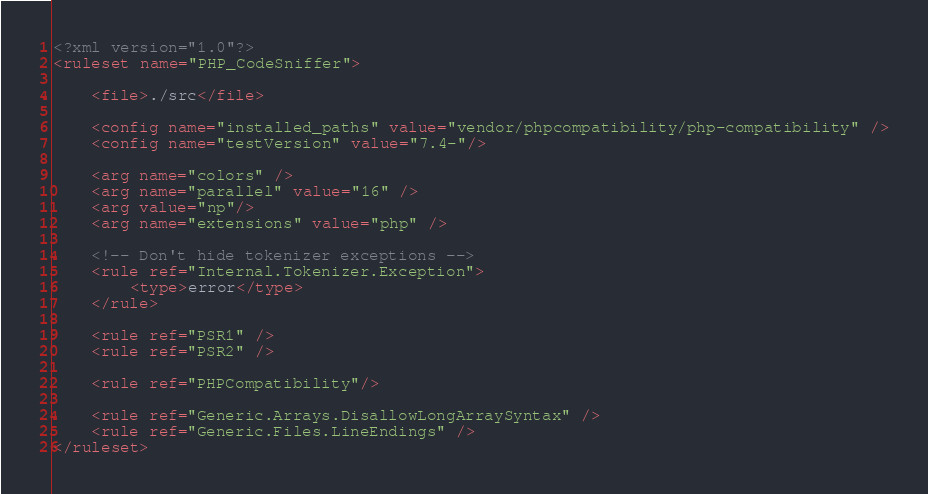<code> <loc_0><loc_0><loc_500><loc_500><_XML_><?xml version="1.0"?>
<ruleset name="PHP_CodeSniffer">

    <file>./src</file>

    <config name="installed_paths" value="vendor/phpcompatibility/php-compatibility" />
    <config name="testVersion" value="7.4-"/>

    <arg name="colors" />
    <arg name="parallel" value="16" />
    <arg value="np"/>
    <arg name="extensions" value="php" />

    <!-- Don't hide tokenizer exceptions -->
    <rule ref="Internal.Tokenizer.Exception">
        <type>error</type>
    </rule>

    <rule ref="PSR1" />
    <rule ref="PSR2" />

    <rule ref="PHPCompatibility"/>

    <rule ref="Generic.Arrays.DisallowLongArraySyntax" />
    <rule ref="Generic.Files.LineEndings" />
</ruleset>
</code> 